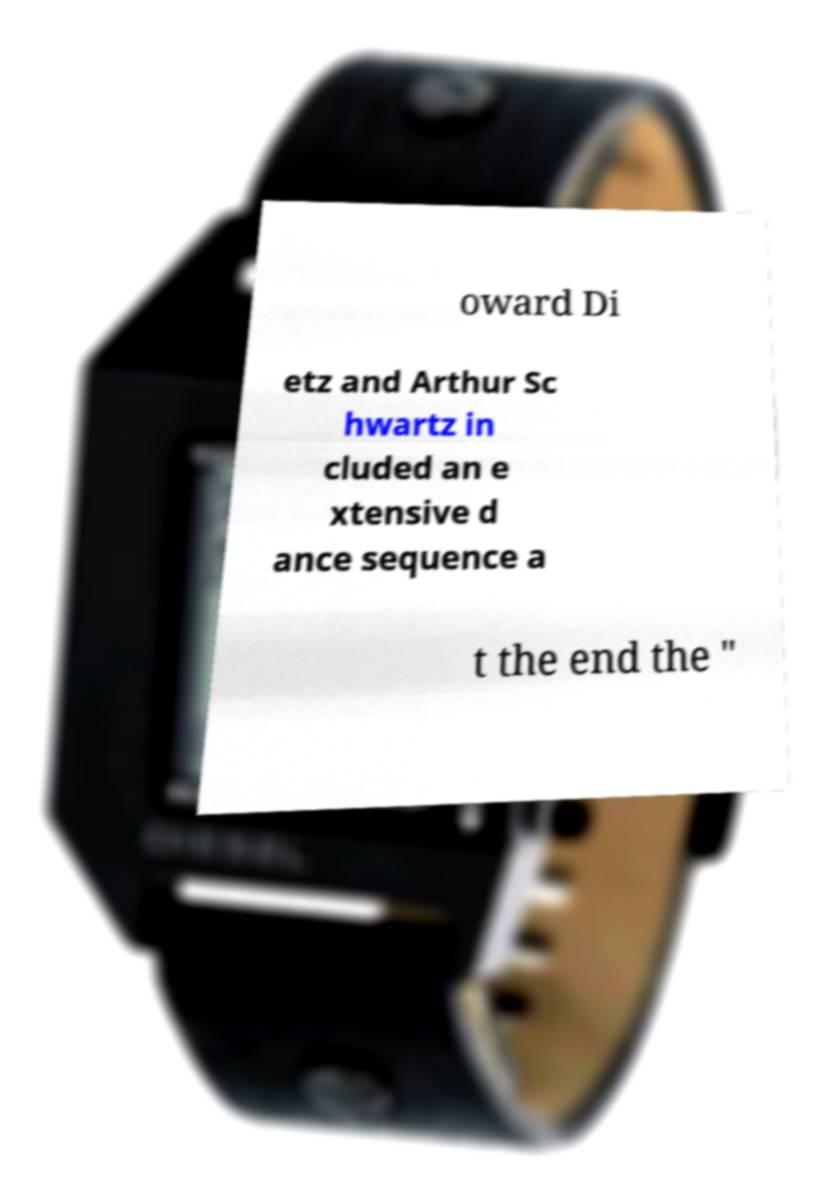Could you assist in decoding the text presented in this image and type it out clearly? oward Di etz and Arthur Sc hwartz in cluded an e xtensive d ance sequence a t the end the " 